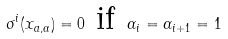<formula> <loc_0><loc_0><loc_500><loc_500>\sigma ^ { i } ( x _ { a , \alpha } ) = 0 \text { if } \alpha _ { i } = \alpha _ { i + 1 } = 1</formula> 